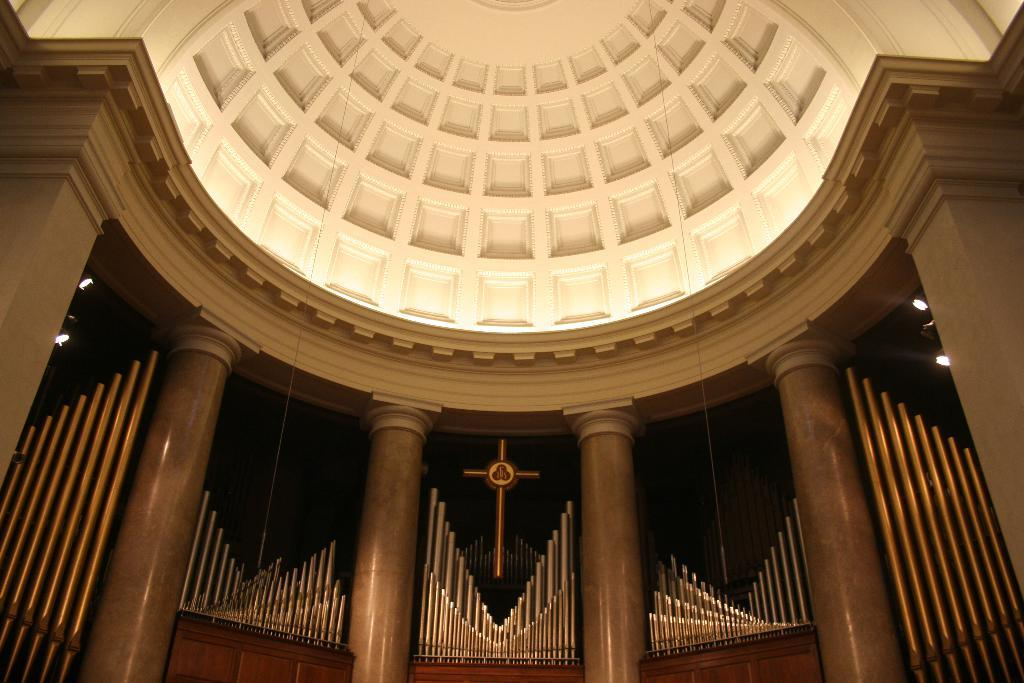What type of location is depicted in the image? The image shows the inside part of a building. What colors can be seen in the building? The building has brown, white, and cream colors. What architectural features are visible in the image? There are pillars visible in the image. Can you see any clouds in the image? No, there are no clouds visible in the image, as it shows the inside part of a building. 